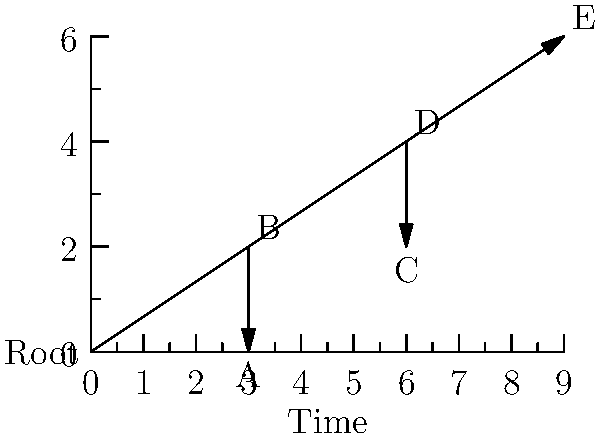As a bioinformatics conference organizer, you're reviewing a presentation on phylogenetic analysis. The presenter shows the above phylogenetic tree diagram. Which species shares the most recent common ancestor with species E? To determine which species shares the most recent common ancestor with species E, we need to follow these steps:

1. Identify the position of species E on the tree. It's at the rightmost tip of the tree.

2. Trace back from E towards the root until we reach the first branching point.

3. At this first branching point, we see that the line splits into two: one leading to E and one leading to D.

4. This branching point represents the most recent common ancestor of E and its closest relative.

5. The species on the other branch from this point is D.

6. Therefore, D shares the most recent common ancestor with E.

7. We can confirm this by noting that all other species (A, B, C) branch off earlier in the tree, meaning their common ancestors with E are older (further back in time) than the common ancestor of D and E.
Answer: D 